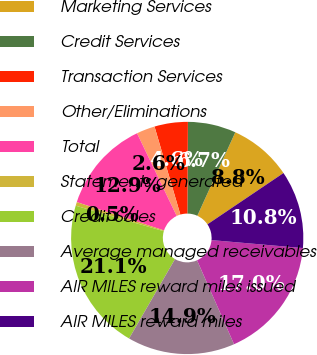Convert chart. <chart><loc_0><loc_0><loc_500><loc_500><pie_chart><fcel>Marketing Services<fcel>Credit Services<fcel>Transaction Services<fcel>Other/Eliminations<fcel>Total<fcel>Statements generated<fcel>Credit Sales<fcel>Average managed receivables<fcel>AIR MILES reward miles issued<fcel>AIR MILES reward miles<nl><fcel>8.76%<fcel>6.7%<fcel>4.64%<fcel>2.57%<fcel>12.89%<fcel>0.51%<fcel>21.14%<fcel>14.95%<fcel>17.01%<fcel>10.83%<nl></chart> 